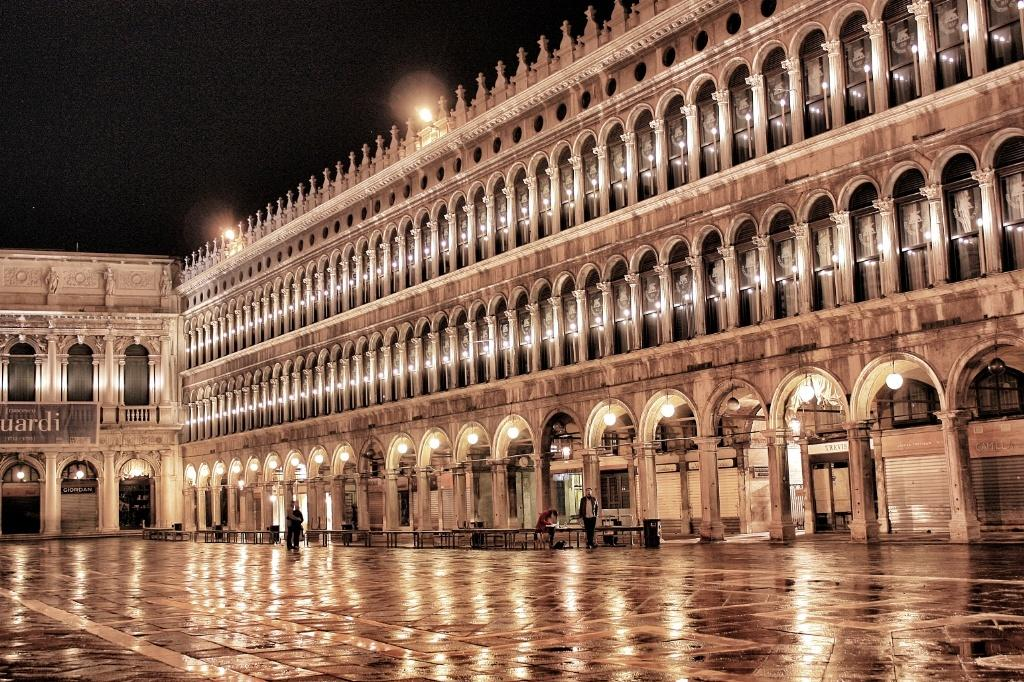What type of structures are present in the image? There are buildings in the image. What can be seen on the floor in the image? There are tables on the floor in the image. Can you describe the people in the image? There are people standing in the image. What is written on the banners in the image? There are banners with text in the image. What can be used to provide illumination in the image? There are lights visible in the image. How many pies are being folded in the image? There are no pies or folding activities present in the image. 